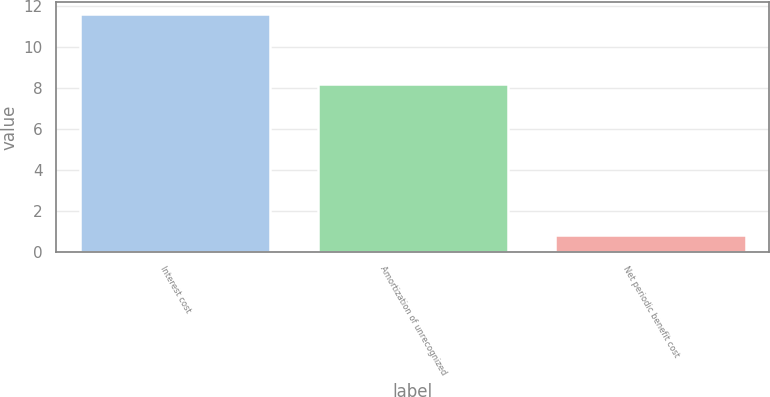Convert chart. <chart><loc_0><loc_0><loc_500><loc_500><bar_chart><fcel>Interest cost<fcel>Amortization of unrecognized<fcel>Net periodic benefit cost<nl><fcel>11.6<fcel>8.2<fcel>0.8<nl></chart> 